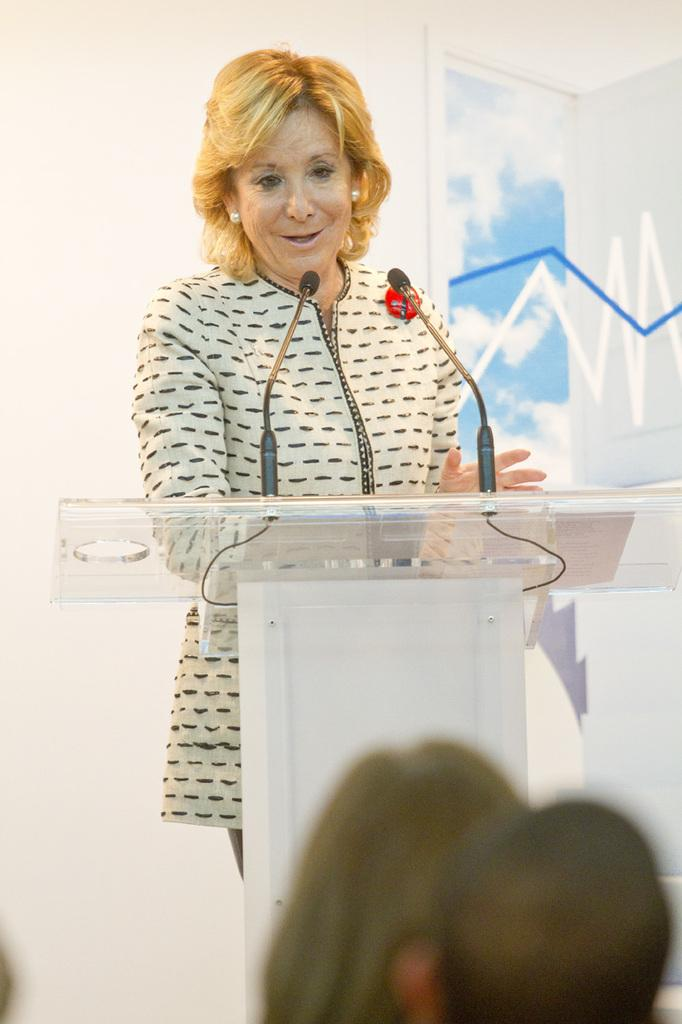What is the person near in the image doing? There is a person standing near a podium in the image. What is the person holding? The person is holding a microphone. Can you describe the people in the image besides the person at the podium? There are heads of other persons visible in the image. What can be seen in the background of the image? There is a wall in the background of the image. What type of unit is being used to measure the pleasure experienced by the person at the podium? There is no indication in the image that any unit is being used to measure pleasure, and the concept of measuring pleasure is not relevant to the image. 